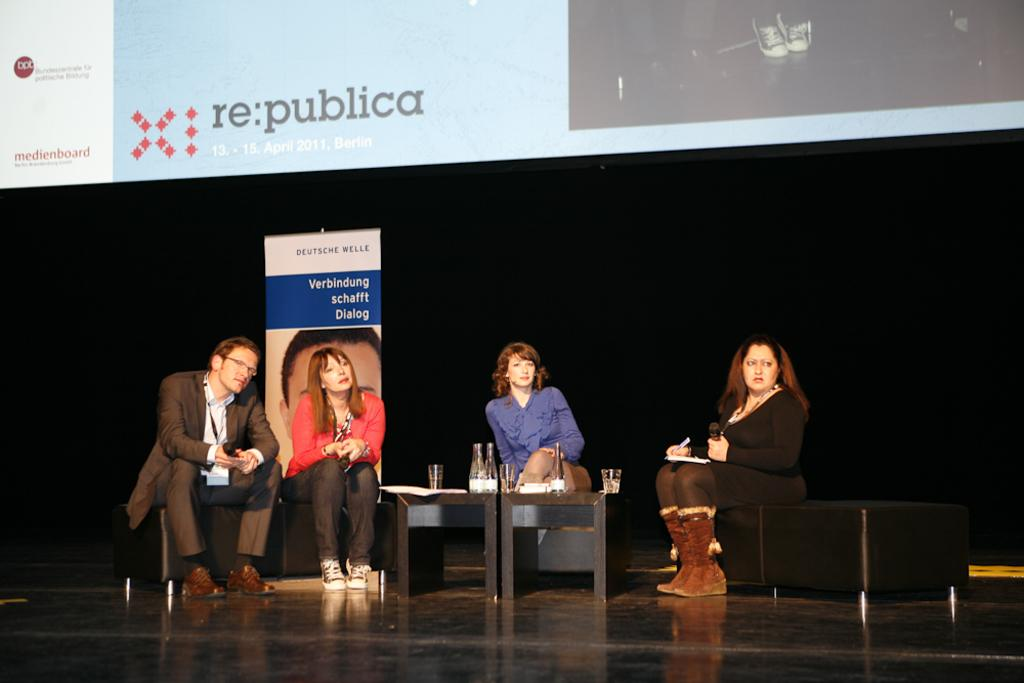How many individuals are present in the image? There are four people in the image. What are the people doing in the image? The four people are sitting in chairs on a stage. Can you describe the gender distribution of the people in the image? Three of the people are women, and one is a man. What type of rule is being enforced by the man in the image? There is no indication in the image that a rule is being enforced, nor is there any man present in the image. 